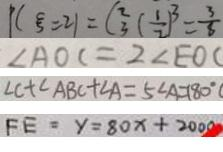<formula> <loc_0><loc_0><loc_500><loc_500>P ( \varepsilon = 2 1 ) = C _ { 3 } ^ { 2 } ( \frac { 1 } { 2 } ) ^ { 3 } = \frac { 3 } { 8 } 
 \angle A O C = 2 \angle E O C 
 \angle C + \angle A B C + \angle A = 5 \angle A = 1 8 0 ^ { \circ } 
 F E = y = 8 0 x + 2 0 0 0</formula> 